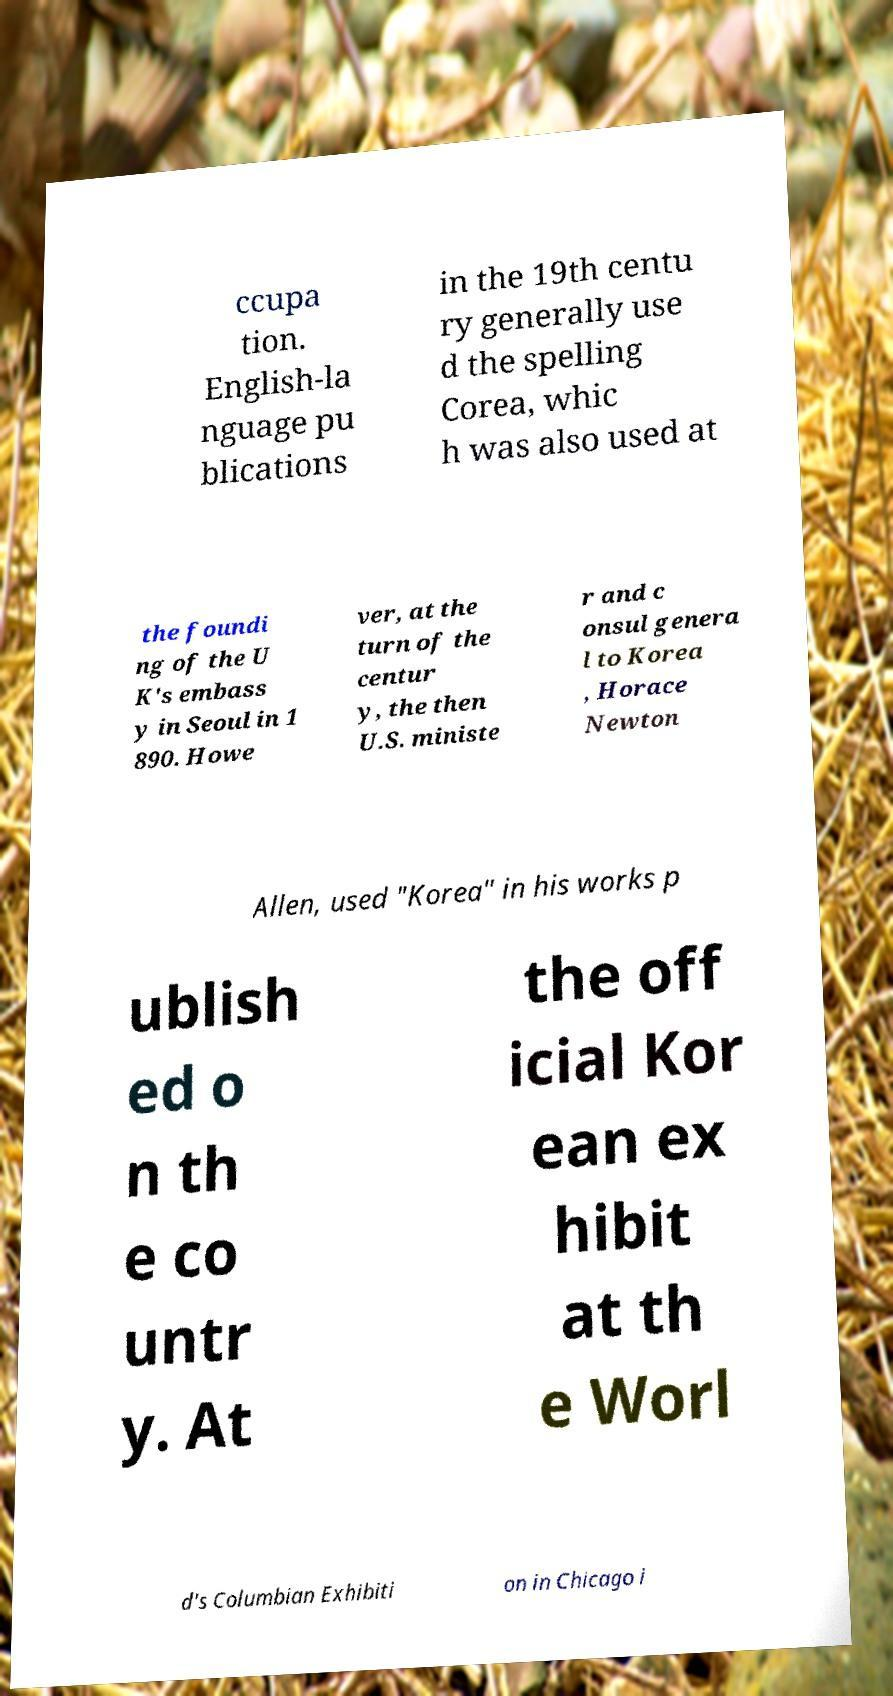Please read and relay the text visible in this image. What does it say? ccupa tion. English-la nguage pu blications in the 19th centu ry generally use d the spelling Corea, whic h was also used at the foundi ng of the U K's embass y in Seoul in 1 890. Howe ver, at the turn of the centur y, the then U.S. ministe r and c onsul genera l to Korea , Horace Newton Allen, used "Korea" in his works p ublish ed o n th e co untr y. At the off icial Kor ean ex hibit at th e Worl d's Columbian Exhibiti on in Chicago i 